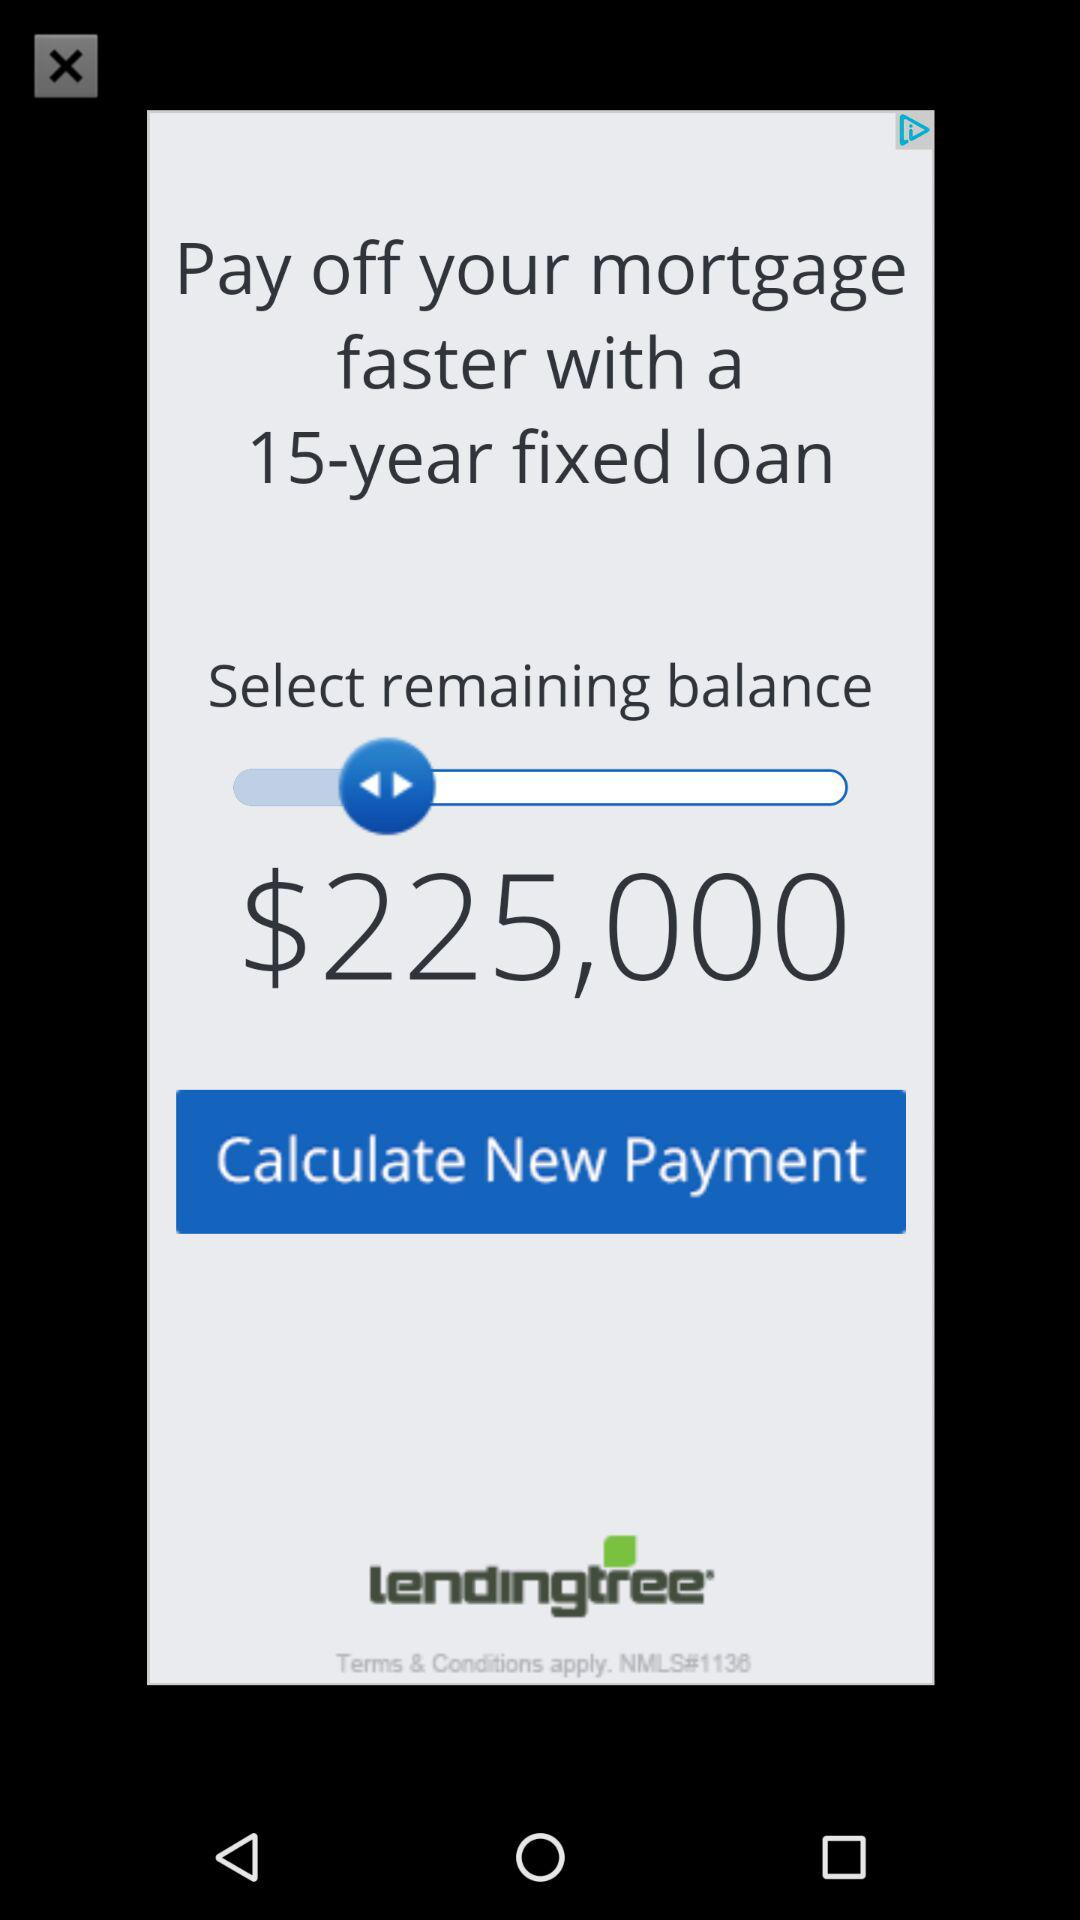How much is the remaining balance on the loan?
Answer the question using a single word or phrase. $225,000 